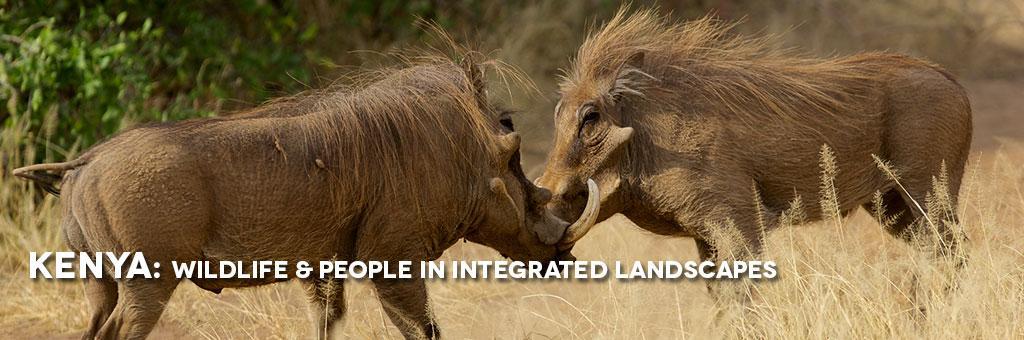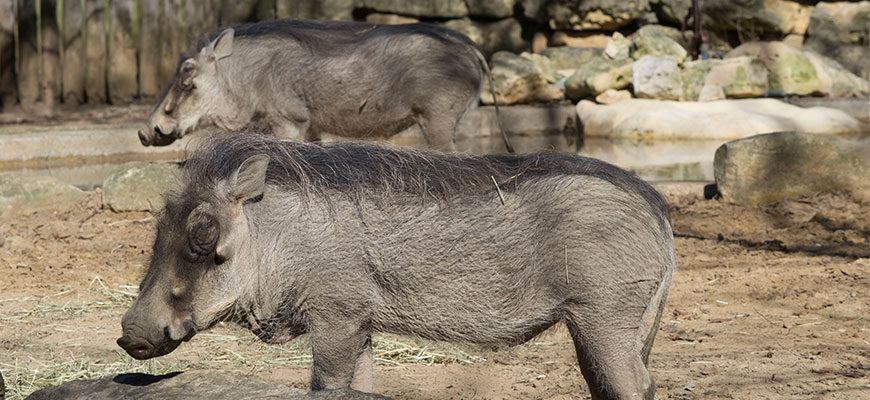The first image is the image on the left, the second image is the image on the right. Examine the images to the left and right. Is the description "In one image two warthog is drinking out of a lake." accurate? Answer yes or no. No. The first image is the image on the left, the second image is the image on the right. For the images displayed, is the sentence "There are two wart hogs in the right image that are both facing towards the left." factually correct? Answer yes or no. Yes. 